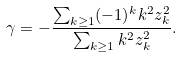<formula> <loc_0><loc_0><loc_500><loc_500>\gamma = - \frac { \sum _ { k \geq 1 } ( - 1 ) ^ { k } k ^ { 2 } z _ { k } ^ { 2 } } { \sum _ { k \geq 1 } k ^ { 2 } z _ { k } ^ { 2 } } .</formula> 